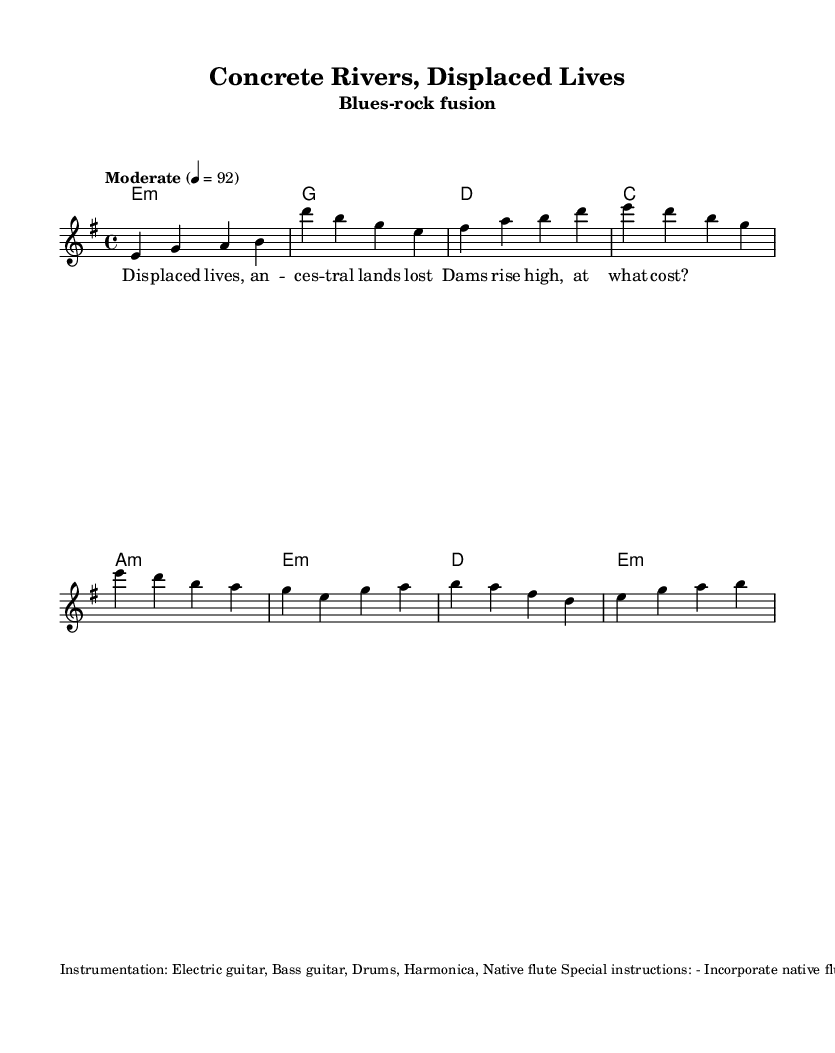What is the key signature of this music? The key signature indicated in the music is E minor, which is typically notated with one sharp (F#). This can be determined from the global settings in the code.
Answer: E minor What is the time signature of this piece? The time signature shown in the music is 4/4, which indicates four beats per measure. This is specified in the global settings of the provided code.
Answer: 4/4 What is the tempo marking for this music? The tempo marking is labeled as "Moderate" with a metronome suggestion of 92 beats per minute. This is provided in the global section of the code.
Answer: Moderate 92 How many chords are used in the verse section? In the verse section, there are four distinct chords used: E minor, G major, D major, and C major. This can be seen in the harmonies section of the code.
Answer: Four What instrument is suggested to be used during the intro and bridge? The instruction states to incorporate the native flute specifically during the intro and bridge sections of the piece, as noted in the special instructions.
Answer: Native flute What is the theme of the lyrics in this song? The lyrics reflect on displacement and loss, particularly focusing on the impacts of dam construction on ancestral lands. This thematic concern is evident in the words provided in the verseWords section.
Answer: Displaced lives, ancestral lands lost How do the verses contribute to the blues musical structure? The verses are structured in a call-and-response fashion typical of blues music, where the melody presents a statement followed by the lyrical response, consistent with the blues tradition. This can be inferred through the melody and the alignment of the lyrics.
Answer: Call-and-response 